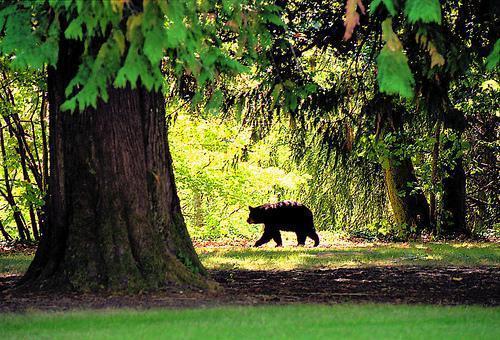How many bears are in the picture?
Give a very brief answer. 1. 